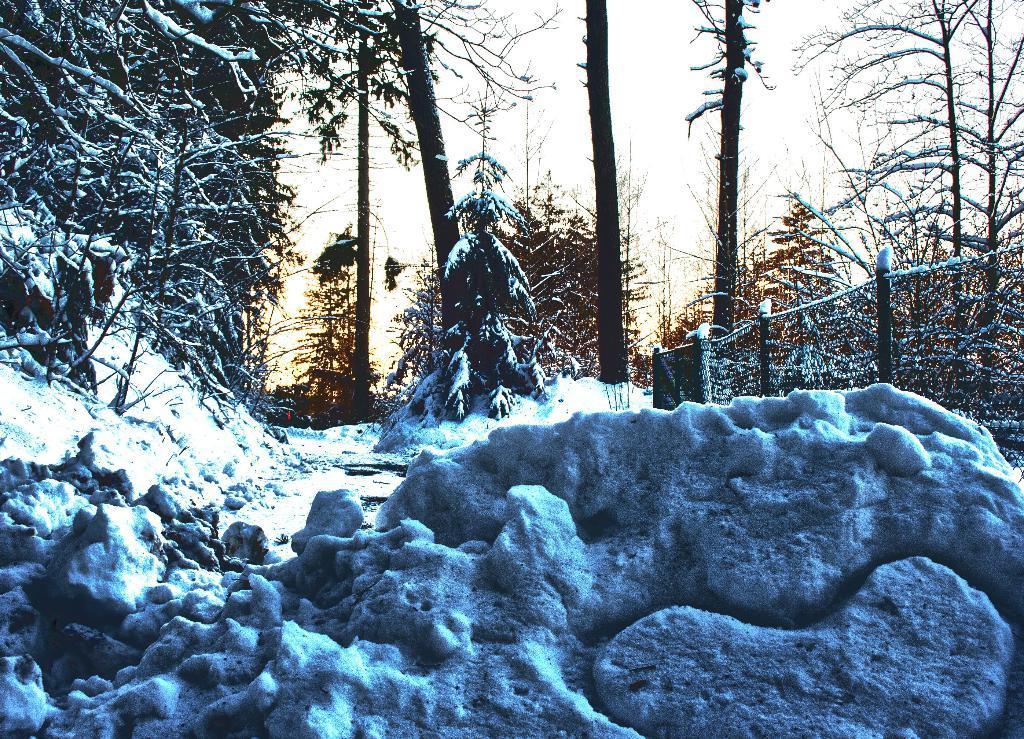Could you give a brief overview of what you see in this image? In this image we can see fence, trees and snow. 